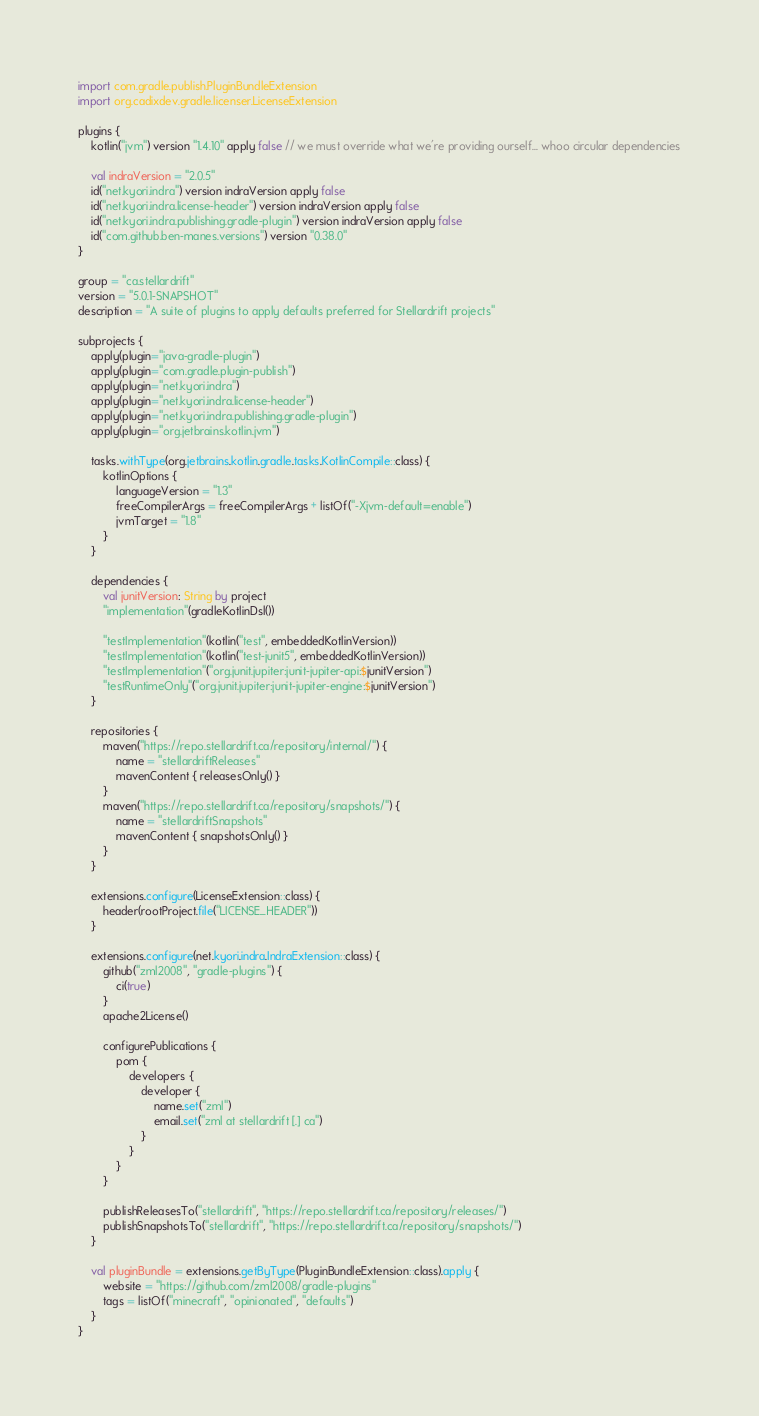<code> <loc_0><loc_0><loc_500><loc_500><_Kotlin_>import com.gradle.publish.PluginBundleExtension
import org.cadixdev.gradle.licenser.LicenseExtension

plugins {
    kotlin("jvm") version "1.4.10" apply false // we must override what we're providing ourself... whoo circular dependencies

    val indraVersion = "2.0.5"
    id("net.kyori.indra") version indraVersion apply false
    id("net.kyori.indra.license-header") version indraVersion apply false
    id("net.kyori.indra.publishing.gradle-plugin") version indraVersion apply false
    id("com.github.ben-manes.versions") version "0.38.0"
}

group = "ca.stellardrift"
version = "5.0.1-SNAPSHOT"
description = "A suite of plugins to apply defaults preferred for Stellardrift projects"

subprojects {
    apply(plugin="java-gradle-plugin")
    apply(plugin="com.gradle.plugin-publish")
    apply(plugin="net.kyori.indra")
    apply(plugin="net.kyori.indra.license-header")
    apply(plugin="net.kyori.indra.publishing.gradle-plugin")
    apply(plugin="org.jetbrains.kotlin.jvm")

    tasks.withType(org.jetbrains.kotlin.gradle.tasks.KotlinCompile::class) {
        kotlinOptions {
            languageVersion = "1.3"
            freeCompilerArgs = freeCompilerArgs + listOf("-Xjvm-default=enable")
            jvmTarget = "1.8"
        }
    }

    dependencies {
        val junitVersion: String by project
        "implementation"(gradleKotlinDsl())

        "testImplementation"(kotlin("test", embeddedKotlinVersion))
        "testImplementation"(kotlin("test-junit5", embeddedKotlinVersion))
        "testImplementation"("org.junit.jupiter:junit-jupiter-api:$junitVersion")
        "testRuntimeOnly"("org.junit.jupiter:junit-jupiter-engine:$junitVersion")
    }

    repositories {
        maven("https://repo.stellardrift.ca/repository/internal/") {
            name = "stellardriftReleases"
            mavenContent { releasesOnly() }
        }
        maven("https://repo.stellardrift.ca/repository/snapshots/") {
            name = "stellardriftSnapshots"
            mavenContent { snapshotsOnly() }
        }
    }

    extensions.configure(LicenseExtension::class) {
        header(rootProject.file("LICENSE_HEADER"))
    }

    extensions.configure(net.kyori.indra.IndraExtension::class) {
        github("zml2008", "gradle-plugins") {
            ci(true)
        }
        apache2License()

        configurePublications {
            pom {
                developers {
                    developer {
                        name.set("zml")
                        email.set("zml at stellardrift [.] ca")
                    }
                }
            }
        }

        publishReleasesTo("stellardrift", "https://repo.stellardrift.ca/repository/releases/")
        publishSnapshotsTo("stellardrift", "https://repo.stellardrift.ca/repository/snapshots/")
    }

    val pluginBundle = extensions.getByType(PluginBundleExtension::class).apply {
        website = "https://github.com/zml2008/gradle-plugins"
        tags = listOf("minecraft", "opinionated", "defaults")
    }
}

</code> 